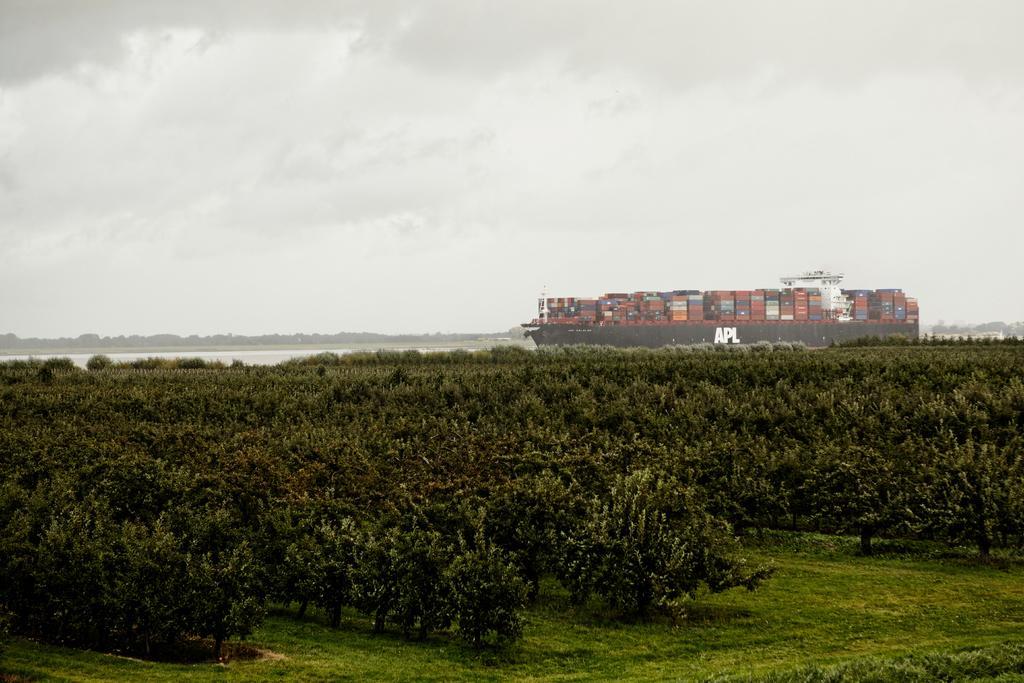Can you describe this image briefly? In the picture we can see a grass surface on it, we can see, full of trees and behind it, we can see water and in it we can see a ship with full of goods on it and behind it we can see trees and sky with clouds. 